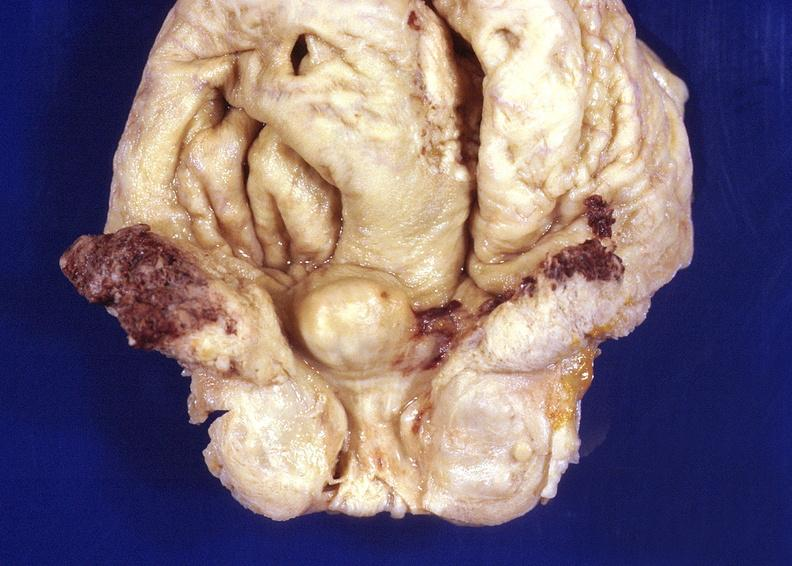where is this?
Answer the question using a single word or phrase. Urinary 